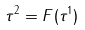<formula> <loc_0><loc_0><loc_500><loc_500>\tau ^ { 2 } = F ( \tau ^ { 1 } )</formula> 